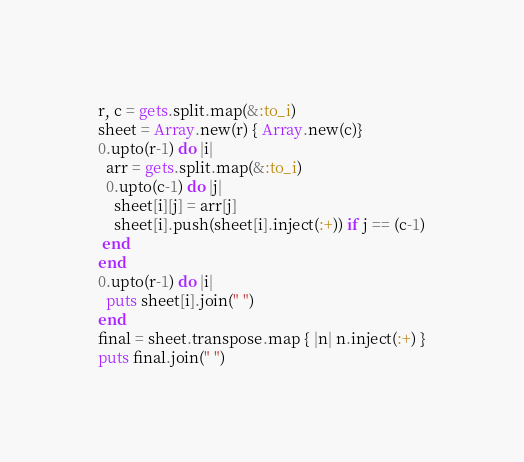<code> <loc_0><loc_0><loc_500><loc_500><_Ruby_>r, c = gets.split.map(&:to_i)
sheet = Array.new(r) { Array.new(c)}
0.upto(r-1) do |i|
  arr = gets.split.map(&:to_i)
  0.upto(c-1) do |j|
    sheet[i][j] = arr[j]
    sheet[i].push(sheet[i].inject(:+)) if j == (c-1)
 end
end
0.upto(r-1) do |i|
  puts sheet[i].join(" ")
end
final = sheet.transpose.map { |n| n.inject(:+) }
puts final.join(" ")

</code> 